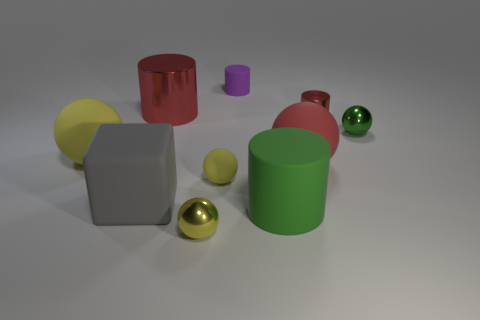There is a small rubber object behind the tiny metallic cylinder; is it the same shape as the tiny green object?
Provide a short and direct response. No. Are there more large green things that are behind the tiny yellow metallic thing than yellow rubber balls that are in front of the big gray object?
Your answer should be compact. Yes. How many small yellow cubes are the same material as the tiny red thing?
Offer a terse response. 0. Is the size of the green sphere the same as the purple matte cylinder?
Your answer should be compact. Yes. What is the color of the tiny rubber ball?
Give a very brief answer. Yellow. How many objects are either purple matte objects or red objects?
Your response must be concise. 4. Are there any other metal things of the same shape as the big shiny thing?
Give a very brief answer. Yes. Do the small cylinder that is to the left of the small red shiny thing and the matte block have the same color?
Provide a short and direct response. No. The large matte object that is behind the red sphere that is right of the big red shiny object is what shape?
Offer a very short reply. Sphere. Are there any gray rubber blocks that have the same size as the green shiny ball?
Your answer should be compact. No. 